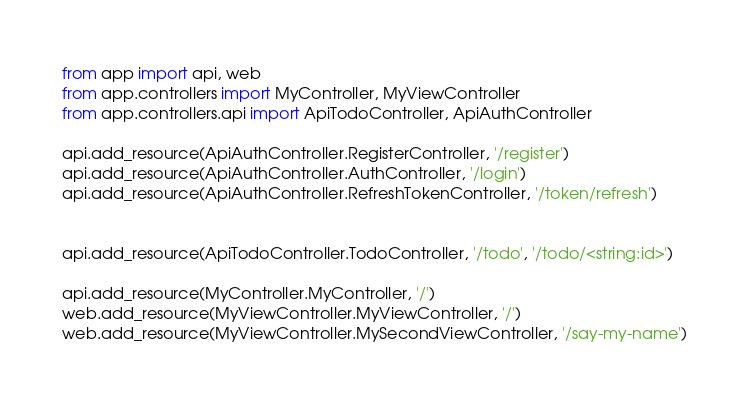Convert code to text. <code><loc_0><loc_0><loc_500><loc_500><_Python_>from app import api, web
from app.controllers import MyController, MyViewController
from app.controllers.api import ApiTodoController, ApiAuthController

api.add_resource(ApiAuthController.RegisterController, '/register')
api.add_resource(ApiAuthController.AuthController, '/login')
api.add_resource(ApiAuthController.RefreshTokenController, '/token/refresh')


api.add_resource(ApiTodoController.TodoController, '/todo', '/todo/<string:id>')

api.add_resource(MyController.MyController, '/')
web.add_resource(MyViewController.MyViewController, '/')
web.add_resource(MyViewController.MySecondViewController, '/say-my-name')
</code> 